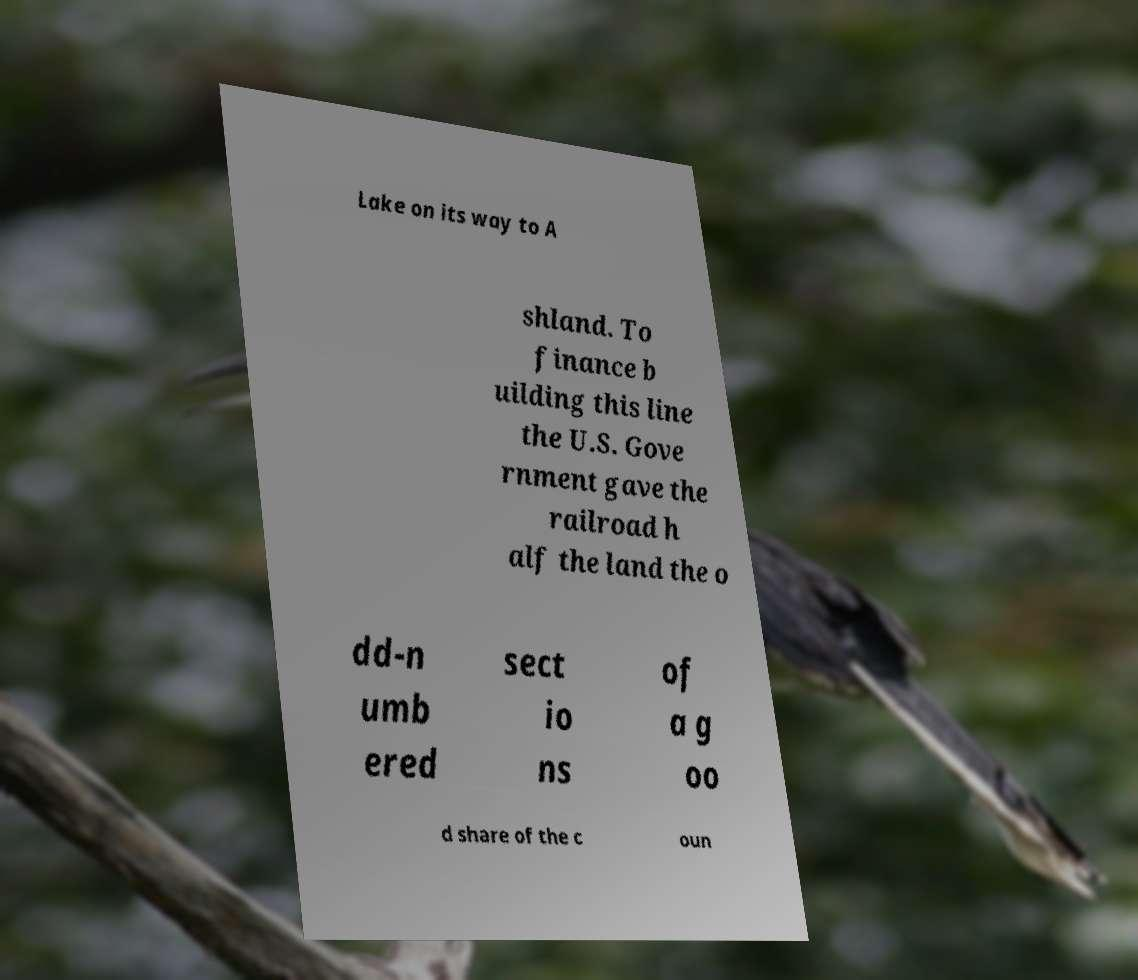What messages or text are displayed in this image? I need them in a readable, typed format. Lake on its way to A shland. To finance b uilding this line the U.S. Gove rnment gave the railroad h alf the land the o dd-n umb ered sect io ns of a g oo d share of the c oun 